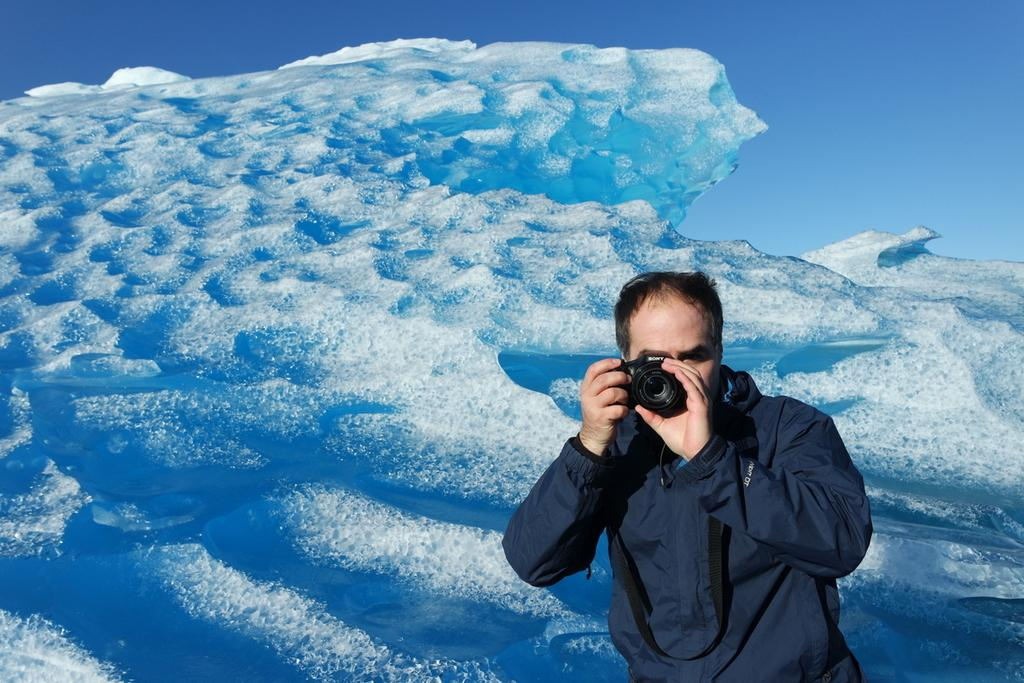Who is present in the image? There is a man in the image. What is the man wearing? The man is wearing a blue jacket. What is the man holding in the image? The man is holding a camera. What can be seen in the background of the image? The background of the image is water. What type of root can be seen growing near the man in the image? There is no root visible in the image; the background is water. 